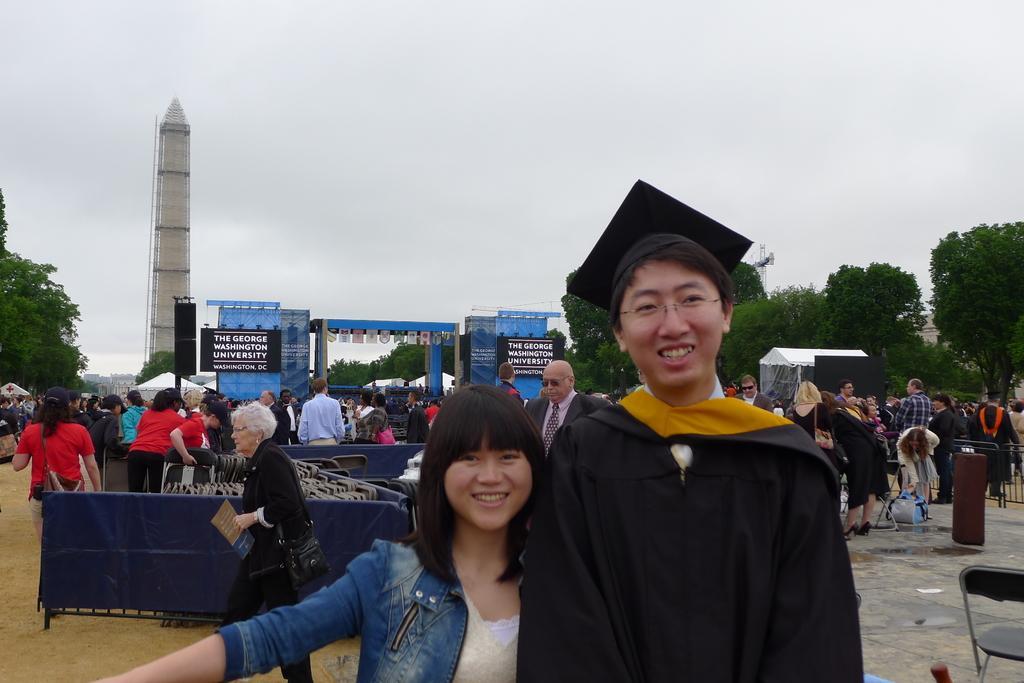Could you give a brief overview of what you see in this image? In this image there is a man and woman are kissing to a photo, in the background there are people doing different activities and there are trees and a tower and a cloudy sky. 